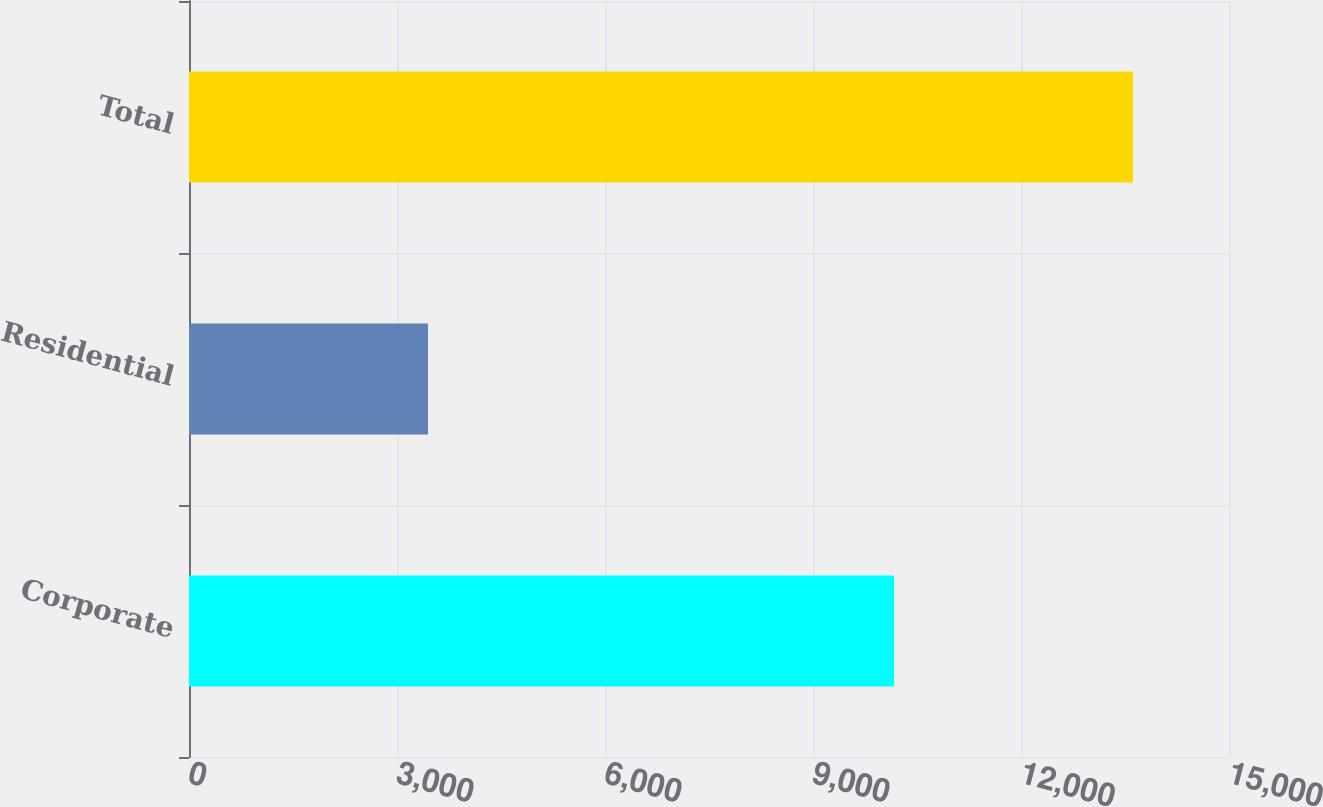Convert chart to OTSL. <chart><loc_0><loc_0><loc_500><loc_500><bar_chart><fcel>Corporate<fcel>Residential<fcel>Total<nl><fcel>10169<fcel>3447<fcel>13616<nl></chart> 